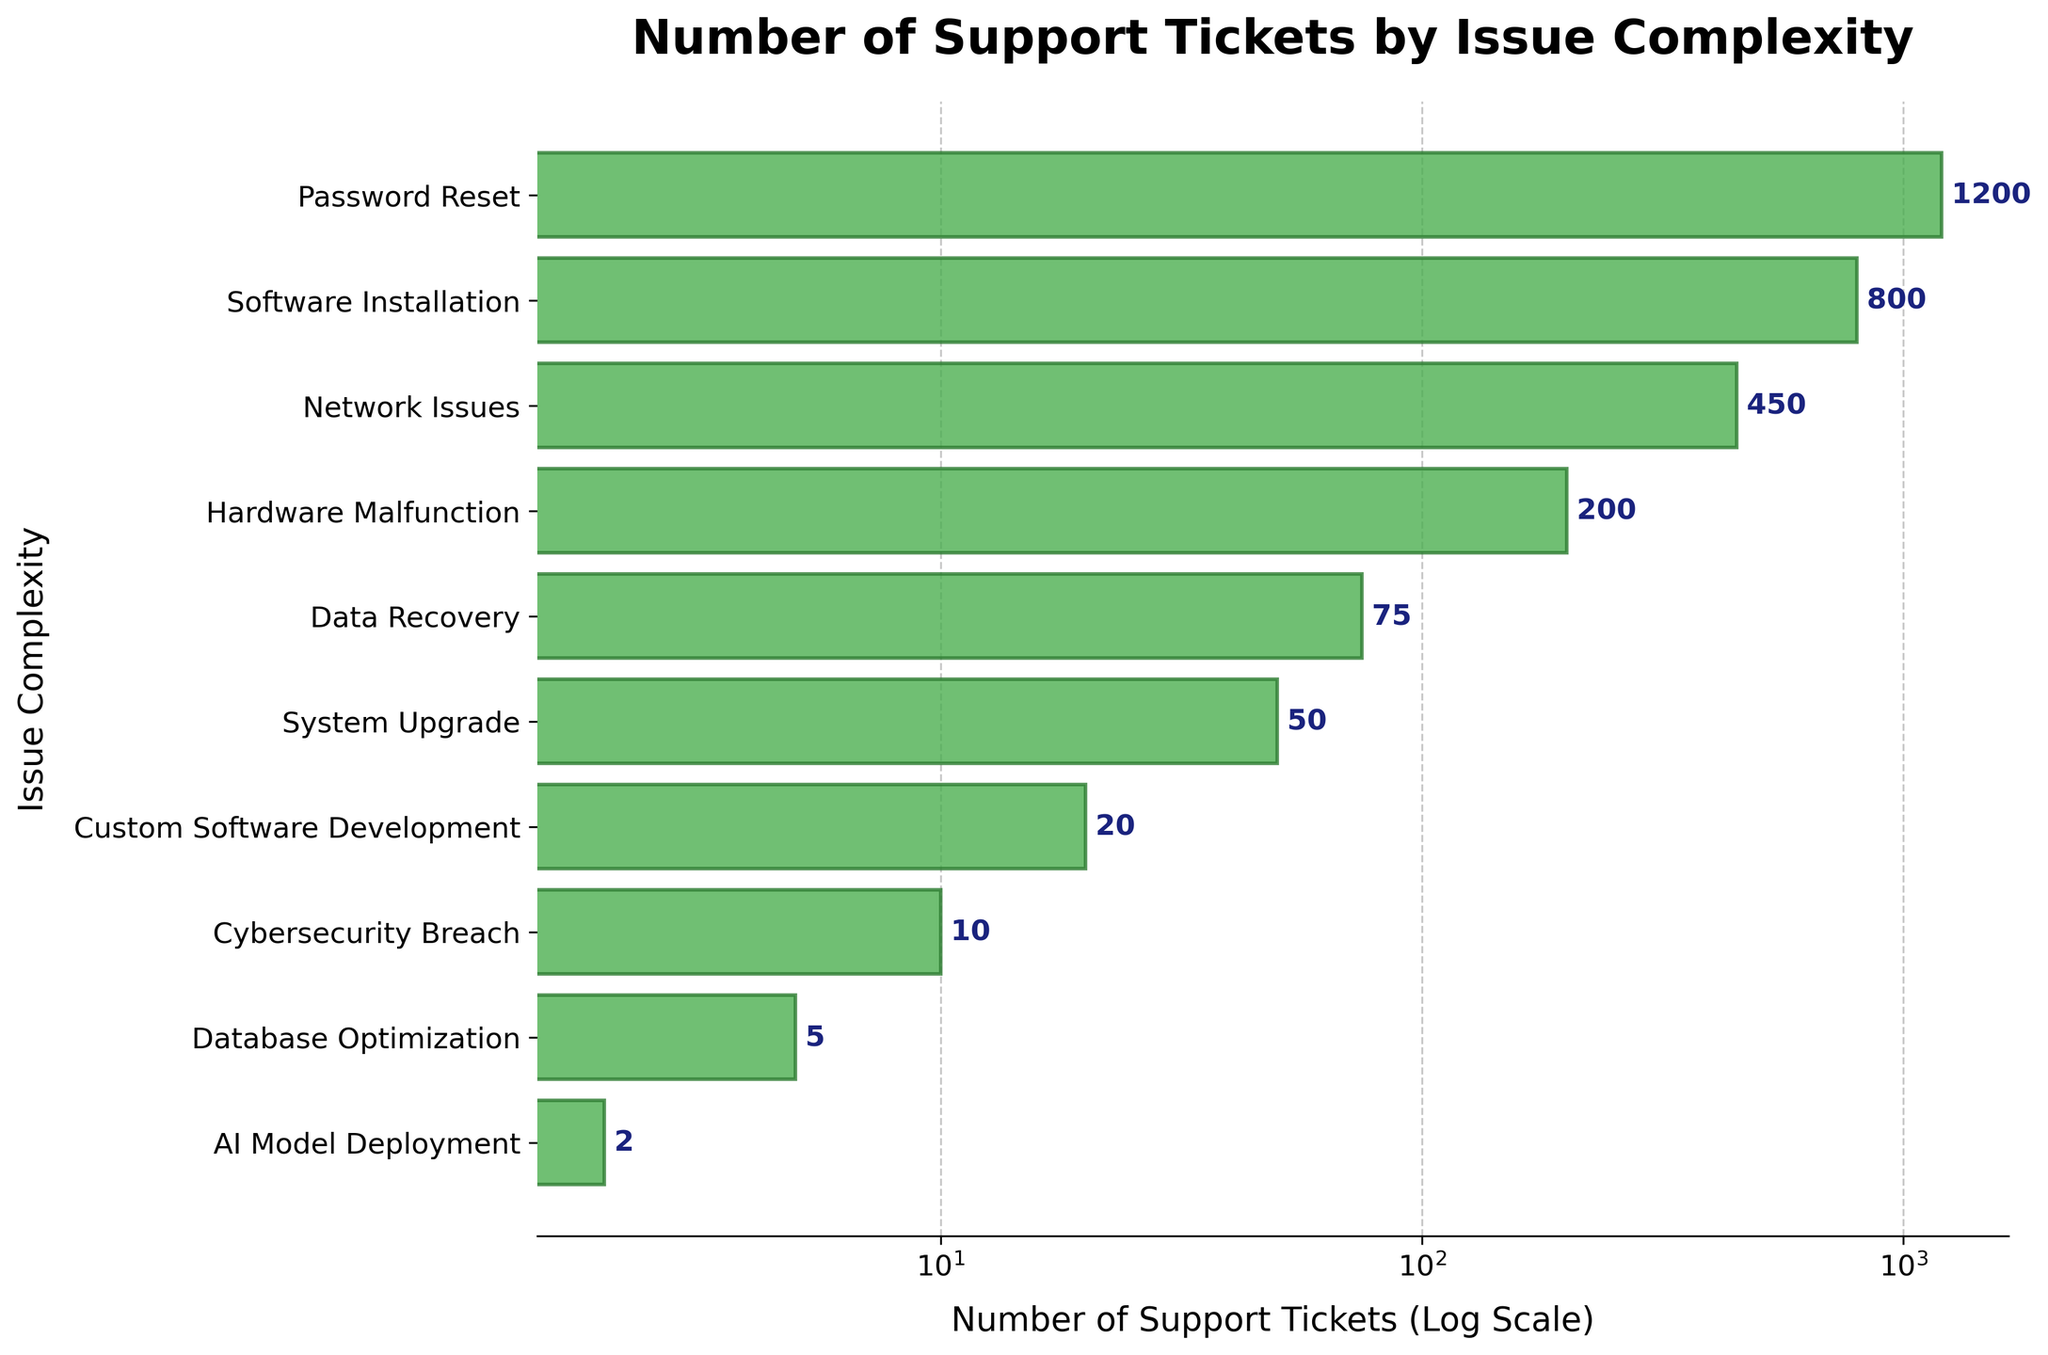What is the title of the plot? The title of the plot is displayed prominently above the horizontal bar chart. It provides a summary of what the chart represents.
Answer: Number of Support Tickets by Issue Complexity What is the issue with the highest number of support tickets? To find the issue with the highest number of support tickets, look for the longest horizontal bar on the chart.
Answer: Password Reset How many support tickets are there for AI Model Deployment? Find the specific bar labeled "AI Model Deployment" and refer to its length, or read the annotation next to it.
Answer: 2 What is the range of support tickets shown in the plot? To determine the range, look at the smallest and largest values on the x-axis, which is scaled logarithmically.
Answer: 2 to 1200 How does the number of tickets for Software Installation compare to Network Issues? Compare the lengths of the bars representing Software Installation and Network Issues to determine which is longer.
Answer: Software Installation has more tickets What is the sum of support tickets for Hardware Malfunction and Data Recovery? Sum the support tickets for Hardware Malfunction (200) and Data Recovery (75).
Answer: 275 Which issues have fewer than 100 support tickets? Identify bars that do not reach the 100 mark on the x-axis.
Answer: Data Recovery, System Upgrade, Custom Software Development, Cybersecurity Breach, Database Optimization, AI Model Deployment What is the median value of support tickets across all issues? List all ticket numbers in ascending order: 2, 5, 10, 20, 50, 75, 200, 450, 800, 1200. The median is the average of the 5th and 6th values.
Answer: 62.5 By what factor is Password Reset more common than Cybersecurity Breach? Divide the number of support tickets for Password Reset (1200) by that for Cybersecurity Breach (10).
Answer: 120 times What is the average number of support tickets for the top three issues? Add the support tickets for the top three issues and divide by 3: (1200 + 800 + 450) / 3.
Answer: 816.67 